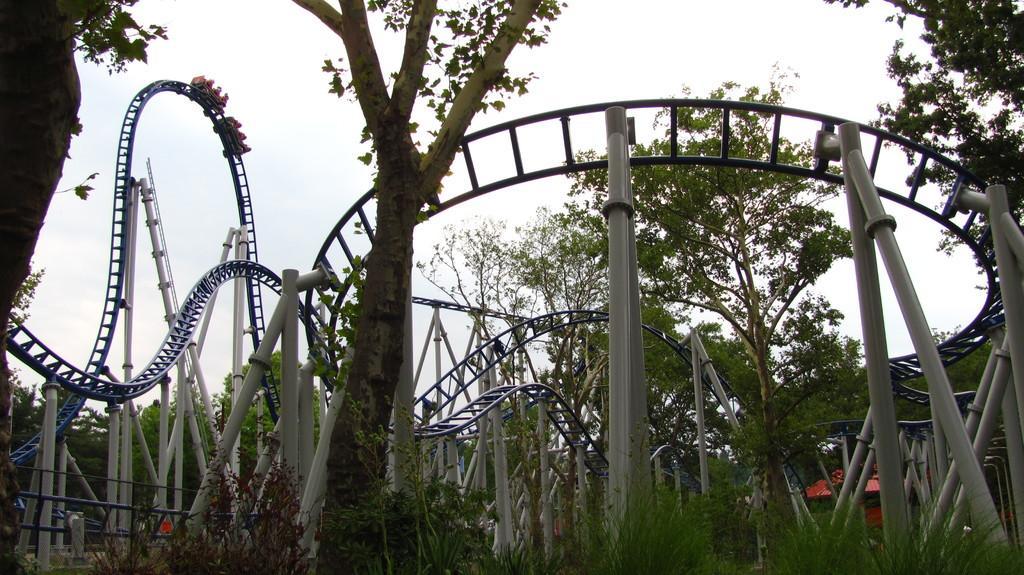Could you give a brief overview of what you see in this image? In the picture I can see roller coaster, pillars, trees and the sky in the background. 